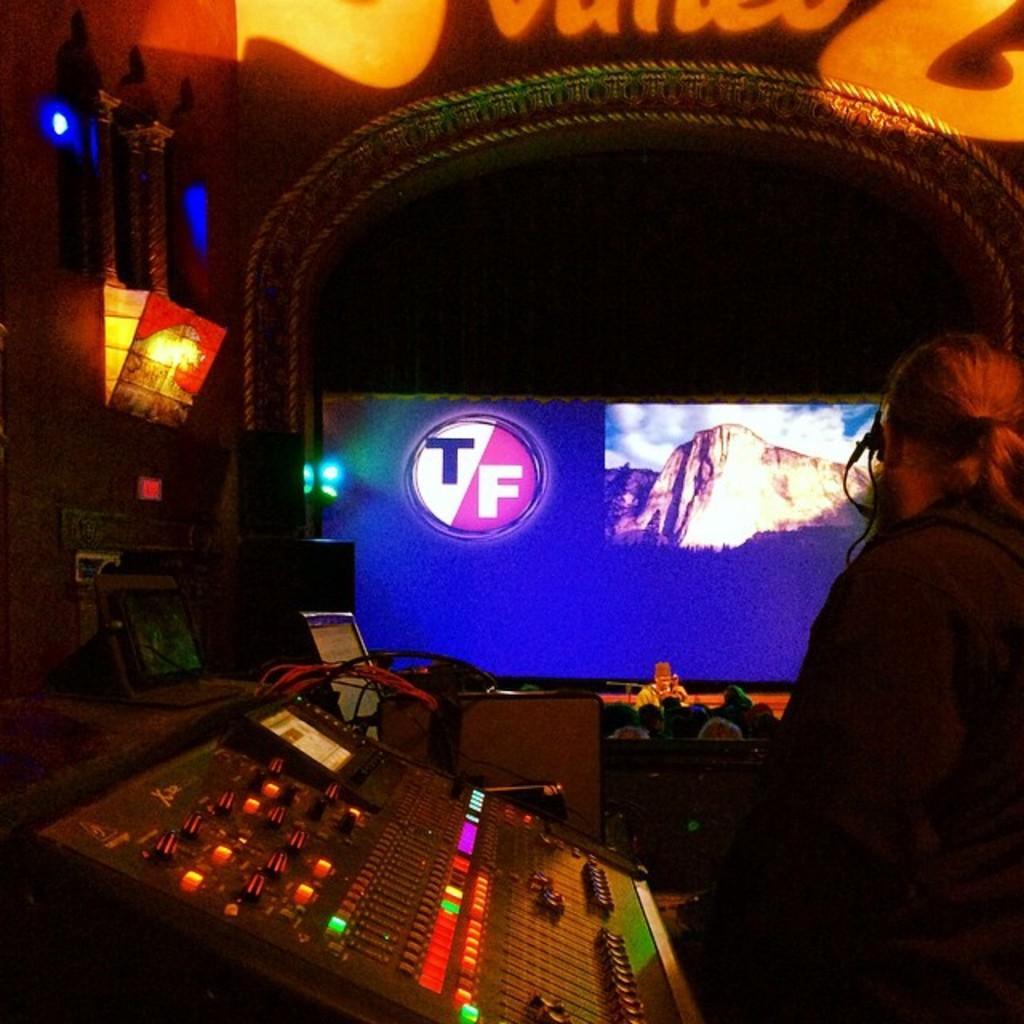Please provide a concise description of this image. In this picture we can see a person is standing on the right side, at the bottom there is an audio controller, in the background there is a screen, we can see some people in the middle, there is a light on the left side, we can also see some wires in the middle. 